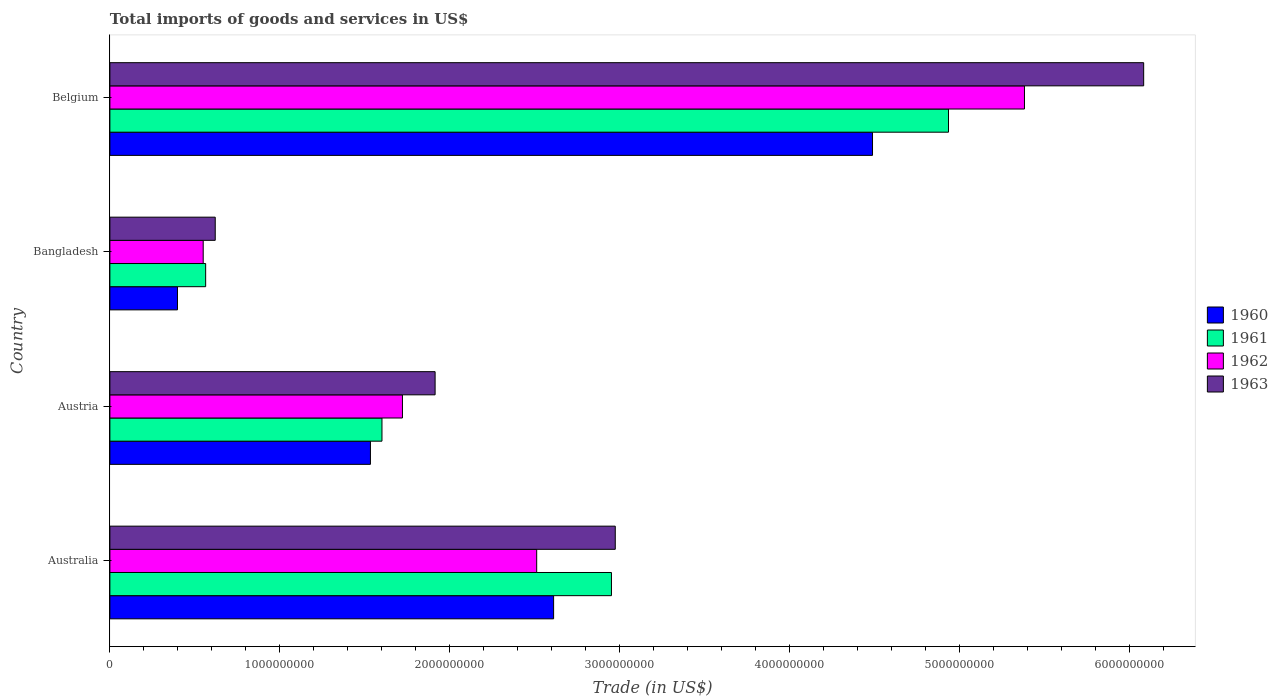How many different coloured bars are there?
Your response must be concise. 4. How many bars are there on the 3rd tick from the top?
Provide a short and direct response. 4. What is the label of the 3rd group of bars from the top?
Your answer should be very brief. Austria. What is the total imports of goods and services in 1961 in Belgium?
Offer a terse response. 4.94e+09. Across all countries, what is the maximum total imports of goods and services in 1960?
Provide a succinct answer. 4.49e+09. Across all countries, what is the minimum total imports of goods and services in 1962?
Offer a very short reply. 5.49e+08. What is the total total imports of goods and services in 1963 in the graph?
Your response must be concise. 1.16e+1. What is the difference between the total imports of goods and services in 1963 in Australia and that in Austria?
Provide a succinct answer. 1.06e+09. What is the difference between the total imports of goods and services in 1960 in Austria and the total imports of goods and services in 1963 in Belgium?
Offer a terse response. -4.55e+09. What is the average total imports of goods and services in 1961 per country?
Give a very brief answer. 2.51e+09. What is the difference between the total imports of goods and services in 1961 and total imports of goods and services in 1960 in Australia?
Your answer should be very brief. 3.40e+08. What is the ratio of the total imports of goods and services in 1962 in Austria to that in Belgium?
Provide a short and direct response. 0.32. Is the total imports of goods and services in 1963 in Austria less than that in Bangladesh?
Ensure brevity in your answer.  No. Is the difference between the total imports of goods and services in 1961 in Bangladesh and Belgium greater than the difference between the total imports of goods and services in 1960 in Bangladesh and Belgium?
Ensure brevity in your answer.  No. What is the difference between the highest and the second highest total imports of goods and services in 1960?
Offer a terse response. 1.88e+09. What is the difference between the highest and the lowest total imports of goods and services in 1961?
Your answer should be very brief. 4.37e+09. In how many countries, is the total imports of goods and services in 1961 greater than the average total imports of goods and services in 1961 taken over all countries?
Offer a very short reply. 2. Is it the case that in every country, the sum of the total imports of goods and services in 1960 and total imports of goods and services in 1962 is greater than the sum of total imports of goods and services in 1963 and total imports of goods and services in 1961?
Ensure brevity in your answer.  No. What does the 2nd bar from the top in Belgium represents?
Provide a short and direct response. 1962. Is it the case that in every country, the sum of the total imports of goods and services in 1961 and total imports of goods and services in 1960 is greater than the total imports of goods and services in 1963?
Provide a succinct answer. Yes. How many bars are there?
Make the answer very short. 16. Are all the bars in the graph horizontal?
Provide a succinct answer. Yes. What is the difference between two consecutive major ticks on the X-axis?
Make the answer very short. 1.00e+09. Are the values on the major ticks of X-axis written in scientific E-notation?
Your answer should be very brief. No. How many legend labels are there?
Make the answer very short. 4. What is the title of the graph?
Offer a very short reply. Total imports of goods and services in US$. Does "2000" appear as one of the legend labels in the graph?
Your response must be concise. No. What is the label or title of the X-axis?
Offer a very short reply. Trade (in US$). What is the label or title of the Y-axis?
Give a very brief answer. Country. What is the Trade (in US$) in 1960 in Australia?
Provide a succinct answer. 2.61e+09. What is the Trade (in US$) in 1961 in Australia?
Your answer should be compact. 2.95e+09. What is the Trade (in US$) of 1962 in Australia?
Your answer should be compact. 2.51e+09. What is the Trade (in US$) in 1963 in Australia?
Your answer should be compact. 2.97e+09. What is the Trade (in US$) in 1960 in Austria?
Keep it short and to the point. 1.53e+09. What is the Trade (in US$) of 1961 in Austria?
Offer a terse response. 1.60e+09. What is the Trade (in US$) of 1962 in Austria?
Your response must be concise. 1.72e+09. What is the Trade (in US$) in 1963 in Austria?
Make the answer very short. 1.91e+09. What is the Trade (in US$) of 1960 in Bangladesh?
Provide a succinct answer. 3.98e+08. What is the Trade (in US$) in 1961 in Bangladesh?
Ensure brevity in your answer.  5.64e+08. What is the Trade (in US$) in 1962 in Bangladesh?
Give a very brief answer. 5.49e+08. What is the Trade (in US$) in 1963 in Bangladesh?
Give a very brief answer. 6.20e+08. What is the Trade (in US$) of 1960 in Belgium?
Offer a very short reply. 4.49e+09. What is the Trade (in US$) in 1961 in Belgium?
Make the answer very short. 4.94e+09. What is the Trade (in US$) in 1962 in Belgium?
Your answer should be compact. 5.38e+09. What is the Trade (in US$) in 1963 in Belgium?
Give a very brief answer. 6.08e+09. Across all countries, what is the maximum Trade (in US$) in 1960?
Offer a terse response. 4.49e+09. Across all countries, what is the maximum Trade (in US$) of 1961?
Your answer should be compact. 4.94e+09. Across all countries, what is the maximum Trade (in US$) in 1962?
Offer a very short reply. 5.38e+09. Across all countries, what is the maximum Trade (in US$) of 1963?
Provide a short and direct response. 6.08e+09. Across all countries, what is the minimum Trade (in US$) of 1960?
Make the answer very short. 3.98e+08. Across all countries, what is the minimum Trade (in US$) of 1961?
Make the answer very short. 5.64e+08. Across all countries, what is the minimum Trade (in US$) in 1962?
Provide a succinct answer. 5.49e+08. Across all countries, what is the minimum Trade (in US$) in 1963?
Offer a very short reply. 6.20e+08. What is the total Trade (in US$) in 1960 in the graph?
Your answer should be compact. 9.03e+09. What is the total Trade (in US$) in 1961 in the graph?
Make the answer very short. 1.01e+1. What is the total Trade (in US$) of 1962 in the graph?
Ensure brevity in your answer.  1.02e+1. What is the total Trade (in US$) in 1963 in the graph?
Your answer should be very brief. 1.16e+1. What is the difference between the Trade (in US$) of 1960 in Australia and that in Austria?
Give a very brief answer. 1.08e+09. What is the difference between the Trade (in US$) of 1961 in Australia and that in Austria?
Your answer should be compact. 1.35e+09. What is the difference between the Trade (in US$) in 1962 in Australia and that in Austria?
Keep it short and to the point. 7.90e+08. What is the difference between the Trade (in US$) in 1963 in Australia and that in Austria?
Keep it short and to the point. 1.06e+09. What is the difference between the Trade (in US$) in 1960 in Australia and that in Bangladesh?
Give a very brief answer. 2.21e+09. What is the difference between the Trade (in US$) of 1961 in Australia and that in Bangladesh?
Ensure brevity in your answer.  2.39e+09. What is the difference between the Trade (in US$) in 1962 in Australia and that in Bangladesh?
Offer a terse response. 1.96e+09. What is the difference between the Trade (in US$) of 1963 in Australia and that in Bangladesh?
Provide a short and direct response. 2.35e+09. What is the difference between the Trade (in US$) in 1960 in Australia and that in Belgium?
Offer a very short reply. -1.88e+09. What is the difference between the Trade (in US$) of 1961 in Australia and that in Belgium?
Give a very brief answer. -1.98e+09. What is the difference between the Trade (in US$) of 1962 in Australia and that in Belgium?
Offer a very short reply. -2.87e+09. What is the difference between the Trade (in US$) of 1963 in Australia and that in Belgium?
Ensure brevity in your answer.  -3.11e+09. What is the difference between the Trade (in US$) of 1960 in Austria and that in Bangladesh?
Ensure brevity in your answer.  1.14e+09. What is the difference between the Trade (in US$) of 1961 in Austria and that in Bangladesh?
Your answer should be very brief. 1.04e+09. What is the difference between the Trade (in US$) in 1962 in Austria and that in Bangladesh?
Give a very brief answer. 1.17e+09. What is the difference between the Trade (in US$) in 1963 in Austria and that in Bangladesh?
Keep it short and to the point. 1.29e+09. What is the difference between the Trade (in US$) of 1960 in Austria and that in Belgium?
Provide a short and direct response. -2.96e+09. What is the difference between the Trade (in US$) of 1961 in Austria and that in Belgium?
Keep it short and to the point. -3.33e+09. What is the difference between the Trade (in US$) of 1962 in Austria and that in Belgium?
Your answer should be compact. -3.66e+09. What is the difference between the Trade (in US$) of 1963 in Austria and that in Belgium?
Give a very brief answer. -4.17e+09. What is the difference between the Trade (in US$) of 1960 in Bangladesh and that in Belgium?
Keep it short and to the point. -4.09e+09. What is the difference between the Trade (in US$) of 1961 in Bangladesh and that in Belgium?
Ensure brevity in your answer.  -4.37e+09. What is the difference between the Trade (in US$) of 1962 in Bangladesh and that in Belgium?
Your answer should be compact. -4.83e+09. What is the difference between the Trade (in US$) of 1963 in Bangladesh and that in Belgium?
Make the answer very short. -5.46e+09. What is the difference between the Trade (in US$) in 1960 in Australia and the Trade (in US$) in 1961 in Austria?
Your answer should be compact. 1.01e+09. What is the difference between the Trade (in US$) in 1960 in Australia and the Trade (in US$) in 1962 in Austria?
Offer a terse response. 8.90e+08. What is the difference between the Trade (in US$) of 1960 in Australia and the Trade (in US$) of 1963 in Austria?
Offer a terse response. 6.98e+08. What is the difference between the Trade (in US$) in 1961 in Australia and the Trade (in US$) in 1962 in Austria?
Give a very brief answer. 1.23e+09. What is the difference between the Trade (in US$) of 1961 in Australia and the Trade (in US$) of 1963 in Austria?
Your response must be concise. 1.04e+09. What is the difference between the Trade (in US$) in 1962 in Australia and the Trade (in US$) in 1963 in Austria?
Make the answer very short. 5.98e+08. What is the difference between the Trade (in US$) of 1960 in Australia and the Trade (in US$) of 1961 in Bangladesh?
Offer a terse response. 2.05e+09. What is the difference between the Trade (in US$) in 1960 in Australia and the Trade (in US$) in 1962 in Bangladesh?
Provide a short and direct response. 2.06e+09. What is the difference between the Trade (in US$) of 1960 in Australia and the Trade (in US$) of 1963 in Bangladesh?
Offer a terse response. 1.99e+09. What is the difference between the Trade (in US$) in 1961 in Australia and the Trade (in US$) in 1962 in Bangladesh?
Make the answer very short. 2.40e+09. What is the difference between the Trade (in US$) in 1961 in Australia and the Trade (in US$) in 1963 in Bangladesh?
Offer a terse response. 2.33e+09. What is the difference between the Trade (in US$) in 1962 in Australia and the Trade (in US$) in 1963 in Bangladesh?
Your response must be concise. 1.89e+09. What is the difference between the Trade (in US$) of 1960 in Australia and the Trade (in US$) of 1961 in Belgium?
Offer a very short reply. -2.32e+09. What is the difference between the Trade (in US$) in 1960 in Australia and the Trade (in US$) in 1962 in Belgium?
Ensure brevity in your answer.  -2.77e+09. What is the difference between the Trade (in US$) in 1960 in Australia and the Trade (in US$) in 1963 in Belgium?
Offer a terse response. -3.47e+09. What is the difference between the Trade (in US$) of 1961 in Australia and the Trade (in US$) of 1962 in Belgium?
Offer a very short reply. -2.43e+09. What is the difference between the Trade (in US$) of 1961 in Australia and the Trade (in US$) of 1963 in Belgium?
Give a very brief answer. -3.13e+09. What is the difference between the Trade (in US$) of 1962 in Australia and the Trade (in US$) of 1963 in Belgium?
Your response must be concise. -3.57e+09. What is the difference between the Trade (in US$) in 1960 in Austria and the Trade (in US$) in 1961 in Bangladesh?
Ensure brevity in your answer.  9.70e+08. What is the difference between the Trade (in US$) in 1960 in Austria and the Trade (in US$) in 1962 in Bangladesh?
Give a very brief answer. 9.84e+08. What is the difference between the Trade (in US$) in 1960 in Austria and the Trade (in US$) in 1963 in Bangladesh?
Your answer should be compact. 9.14e+08. What is the difference between the Trade (in US$) in 1961 in Austria and the Trade (in US$) in 1962 in Bangladesh?
Your answer should be very brief. 1.05e+09. What is the difference between the Trade (in US$) of 1961 in Austria and the Trade (in US$) of 1963 in Bangladesh?
Your answer should be compact. 9.81e+08. What is the difference between the Trade (in US$) in 1962 in Austria and the Trade (in US$) in 1963 in Bangladesh?
Provide a short and direct response. 1.10e+09. What is the difference between the Trade (in US$) in 1960 in Austria and the Trade (in US$) in 1961 in Belgium?
Your answer should be very brief. -3.40e+09. What is the difference between the Trade (in US$) in 1960 in Austria and the Trade (in US$) in 1962 in Belgium?
Provide a succinct answer. -3.85e+09. What is the difference between the Trade (in US$) of 1960 in Austria and the Trade (in US$) of 1963 in Belgium?
Offer a very short reply. -4.55e+09. What is the difference between the Trade (in US$) in 1961 in Austria and the Trade (in US$) in 1962 in Belgium?
Give a very brief answer. -3.78e+09. What is the difference between the Trade (in US$) in 1961 in Austria and the Trade (in US$) in 1963 in Belgium?
Give a very brief answer. -4.48e+09. What is the difference between the Trade (in US$) in 1962 in Austria and the Trade (in US$) in 1963 in Belgium?
Your answer should be compact. -4.36e+09. What is the difference between the Trade (in US$) of 1960 in Bangladesh and the Trade (in US$) of 1961 in Belgium?
Your response must be concise. -4.54e+09. What is the difference between the Trade (in US$) in 1960 in Bangladesh and the Trade (in US$) in 1962 in Belgium?
Offer a very short reply. -4.99e+09. What is the difference between the Trade (in US$) of 1960 in Bangladesh and the Trade (in US$) of 1963 in Belgium?
Your response must be concise. -5.69e+09. What is the difference between the Trade (in US$) in 1961 in Bangladesh and the Trade (in US$) in 1962 in Belgium?
Provide a short and direct response. -4.82e+09. What is the difference between the Trade (in US$) of 1961 in Bangladesh and the Trade (in US$) of 1963 in Belgium?
Your answer should be very brief. -5.52e+09. What is the difference between the Trade (in US$) in 1962 in Bangladesh and the Trade (in US$) in 1963 in Belgium?
Your answer should be compact. -5.54e+09. What is the average Trade (in US$) in 1960 per country?
Your answer should be very brief. 2.26e+09. What is the average Trade (in US$) in 1961 per country?
Ensure brevity in your answer.  2.51e+09. What is the average Trade (in US$) in 1962 per country?
Keep it short and to the point. 2.54e+09. What is the average Trade (in US$) of 1963 per country?
Offer a very short reply. 2.90e+09. What is the difference between the Trade (in US$) in 1960 and Trade (in US$) in 1961 in Australia?
Make the answer very short. -3.40e+08. What is the difference between the Trade (in US$) in 1960 and Trade (in US$) in 1962 in Australia?
Your response must be concise. 9.97e+07. What is the difference between the Trade (in US$) in 1960 and Trade (in US$) in 1963 in Australia?
Ensure brevity in your answer.  -3.63e+08. What is the difference between the Trade (in US$) of 1961 and Trade (in US$) of 1962 in Australia?
Offer a very short reply. 4.40e+08. What is the difference between the Trade (in US$) in 1961 and Trade (in US$) in 1963 in Australia?
Give a very brief answer. -2.24e+07. What is the difference between the Trade (in US$) of 1962 and Trade (in US$) of 1963 in Australia?
Ensure brevity in your answer.  -4.63e+08. What is the difference between the Trade (in US$) of 1960 and Trade (in US$) of 1961 in Austria?
Make the answer very short. -6.78e+07. What is the difference between the Trade (in US$) of 1960 and Trade (in US$) of 1962 in Austria?
Provide a short and direct response. -1.88e+08. What is the difference between the Trade (in US$) in 1960 and Trade (in US$) in 1963 in Austria?
Make the answer very short. -3.81e+08. What is the difference between the Trade (in US$) in 1961 and Trade (in US$) in 1962 in Austria?
Provide a succinct answer. -1.21e+08. What is the difference between the Trade (in US$) in 1961 and Trade (in US$) in 1963 in Austria?
Provide a succinct answer. -3.13e+08. What is the difference between the Trade (in US$) of 1962 and Trade (in US$) of 1963 in Austria?
Make the answer very short. -1.92e+08. What is the difference between the Trade (in US$) of 1960 and Trade (in US$) of 1961 in Bangladesh?
Make the answer very short. -1.66e+08. What is the difference between the Trade (in US$) of 1960 and Trade (in US$) of 1962 in Bangladesh?
Give a very brief answer. -1.51e+08. What is the difference between the Trade (in US$) of 1960 and Trade (in US$) of 1963 in Bangladesh?
Your response must be concise. -2.22e+08. What is the difference between the Trade (in US$) in 1961 and Trade (in US$) in 1962 in Bangladesh?
Keep it short and to the point. 1.45e+07. What is the difference between the Trade (in US$) in 1961 and Trade (in US$) in 1963 in Bangladesh?
Ensure brevity in your answer.  -5.64e+07. What is the difference between the Trade (in US$) in 1962 and Trade (in US$) in 1963 in Bangladesh?
Make the answer very short. -7.08e+07. What is the difference between the Trade (in US$) in 1960 and Trade (in US$) in 1961 in Belgium?
Ensure brevity in your answer.  -4.47e+08. What is the difference between the Trade (in US$) of 1960 and Trade (in US$) of 1962 in Belgium?
Your response must be concise. -8.94e+08. What is the difference between the Trade (in US$) in 1960 and Trade (in US$) in 1963 in Belgium?
Offer a terse response. -1.60e+09. What is the difference between the Trade (in US$) in 1961 and Trade (in US$) in 1962 in Belgium?
Ensure brevity in your answer.  -4.47e+08. What is the difference between the Trade (in US$) in 1961 and Trade (in US$) in 1963 in Belgium?
Your answer should be very brief. -1.15e+09. What is the difference between the Trade (in US$) in 1962 and Trade (in US$) in 1963 in Belgium?
Ensure brevity in your answer.  -7.02e+08. What is the ratio of the Trade (in US$) of 1960 in Australia to that in Austria?
Offer a very short reply. 1.7. What is the ratio of the Trade (in US$) of 1961 in Australia to that in Austria?
Keep it short and to the point. 1.84. What is the ratio of the Trade (in US$) in 1962 in Australia to that in Austria?
Give a very brief answer. 1.46. What is the ratio of the Trade (in US$) of 1963 in Australia to that in Austria?
Your answer should be very brief. 1.55. What is the ratio of the Trade (in US$) of 1960 in Australia to that in Bangladesh?
Provide a succinct answer. 6.56. What is the ratio of the Trade (in US$) in 1961 in Australia to that in Bangladesh?
Provide a short and direct response. 5.24. What is the ratio of the Trade (in US$) of 1962 in Australia to that in Bangladesh?
Provide a succinct answer. 4.57. What is the ratio of the Trade (in US$) in 1963 in Australia to that in Bangladesh?
Give a very brief answer. 4.8. What is the ratio of the Trade (in US$) of 1960 in Australia to that in Belgium?
Your answer should be compact. 0.58. What is the ratio of the Trade (in US$) of 1961 in Australia to that in Belgium?
Offer a terse response. 0.6. What is the ratio of the Trade (in US$) in 1962 in Australia to that in Belgium?
Provide a short and direct response. 0.47. What is the ratio of the Trade (in US$) of 1963 in Australia to that in Belgium?
Give a very brief answer. 0.49. What is the ratio of the Trade (in US$) of 1960 in Austria to that in Bangladesh?
Give a very brief answer. 3.85. What is the ratio of the Trade (in US$) of 1961 in Austria to that in Bangladesh?
Make the answer very short. 2.84. What is the ratio of the Trade (in US$) of 1962 in Austria to that in Bangladesh?
Your response must be concise. 3.14. What is the ratio of the Trade (in US$) in 1963 in Austria to that in Bangladesh?
Offer a very short reply. 3.09. What is the ratio of the Trade (in US$) of 1960 in Austria to that in Belgium?
Make the answer very short. 0.34. What is the ratio of the Trade (in US$) of 1961 in Austria to that in Belgium?
Provide a succinct answer. 0.32. What is the ratio of the Trade (in US$) of 1962 in Austria to that in Belgium?
Offer a very short reply. 0.32. What is the ratio of the Trade (in US$) of 1963 in Austria to that in Belgium?
Your response must be concise. 0.31. What is the ratio of the Trade (in US$) of 1960 in Bangladesh to that in Belgium?
Your answer should be very brief. 0.09. What is the ratio of the Trade (in US$) of 1961 in Bangladesh to that in Belgium?
Your response must be concise. 0.11. What is the ratio of the Trade (in US$) in 1962 in Bangladesh to that in Belgium?
Provide a succinct answer. 0.1. What is the ratio of the Trade (in US$) in 1963 in Bangladesh to that in Belgium?
Provide a succinct answer. 0.1. What is the difference between the highest and the second highest Trade (in US$) of 1960?
Make the answer very short. 1.88e+09. What is the difference between the highest and the second highest Trade (in US$) in 1961?
Offer a very short reply. 1.98e+09. What is the difference between the highest and the second highest Trade (in US$) of 1962?
Make the answer very short. 2.87e+09. What is the difference between the highest and the second highest Trade (in US$) of 1963?
Offer a terse response. 3.11e+09. What is the difference between the highest and the lowest Trade (in US$) in 1960?
Offer a terse response. 4.09e+09. What is the difference between the highest and the lowest Trade (in US$) of 1961?
Your answer should be very brief. 4.37e+09. What is the difference between the highest and the lowest Trade (in US$) of 1962?
Your answer should be very brief. 4.83e+09. What is the difference between the highest and the lowest Trade (in US$) in 1963?
Give a very brief answer. 5.46e+09. 